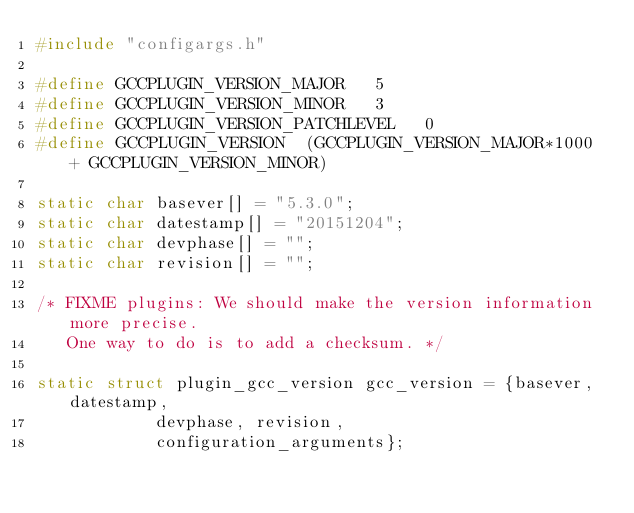<code> <loc_0><loc_0><loc_500><loc_500><_C_>#include "configargs.h"

#define GCCPLUGIN_VERSION_MAJOR   5
#define GCCPLUGIN_VERSION_MINOR   3
#define GCCPLUGIN_VERSION_PATCHLEVEL   0
#define GCCPLUGIN_VERSION  (GCCPLUGIN_VERSION_MAJOR*1000 + GCCPLUGIN_VERSION_MINOR)

static char basever[] = "5.3.0";
static char datestamp[] = "20151204";
static char devphase[] = "";
static char revision[] = "";

/* FIXME plugins: We should make the version information more precise.
   One way to do is to add a checksum. */

static struct plugin_gcc_version gcc_version = {basever, datestamp,
						devphase, revision,
						configuration_arguments};
</code> 